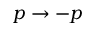Convert formula to latex. <formula><loc_0><loc_0><loc_500><loc_500>p \to - p</formula> 